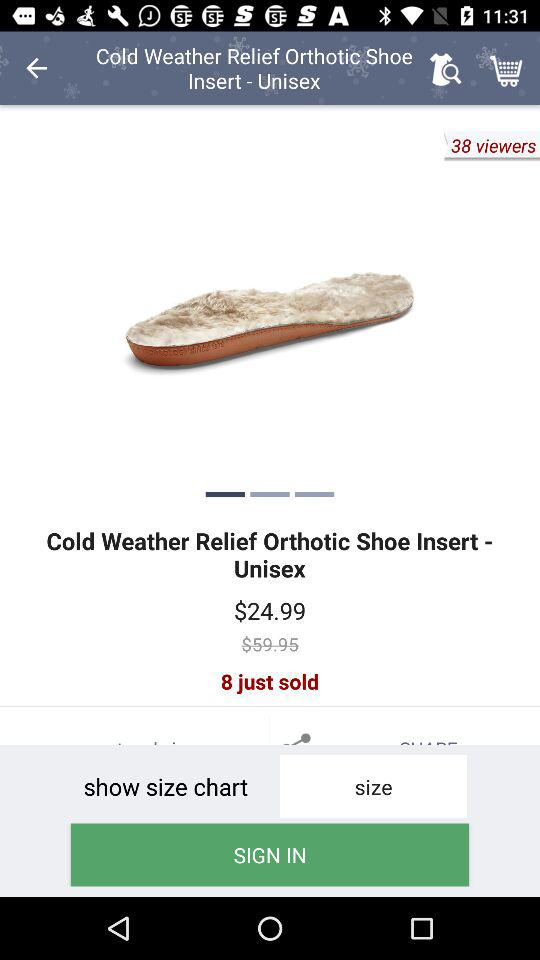How many more viewers are there than products sold?
Answer the question using a single word or phrase. 30 